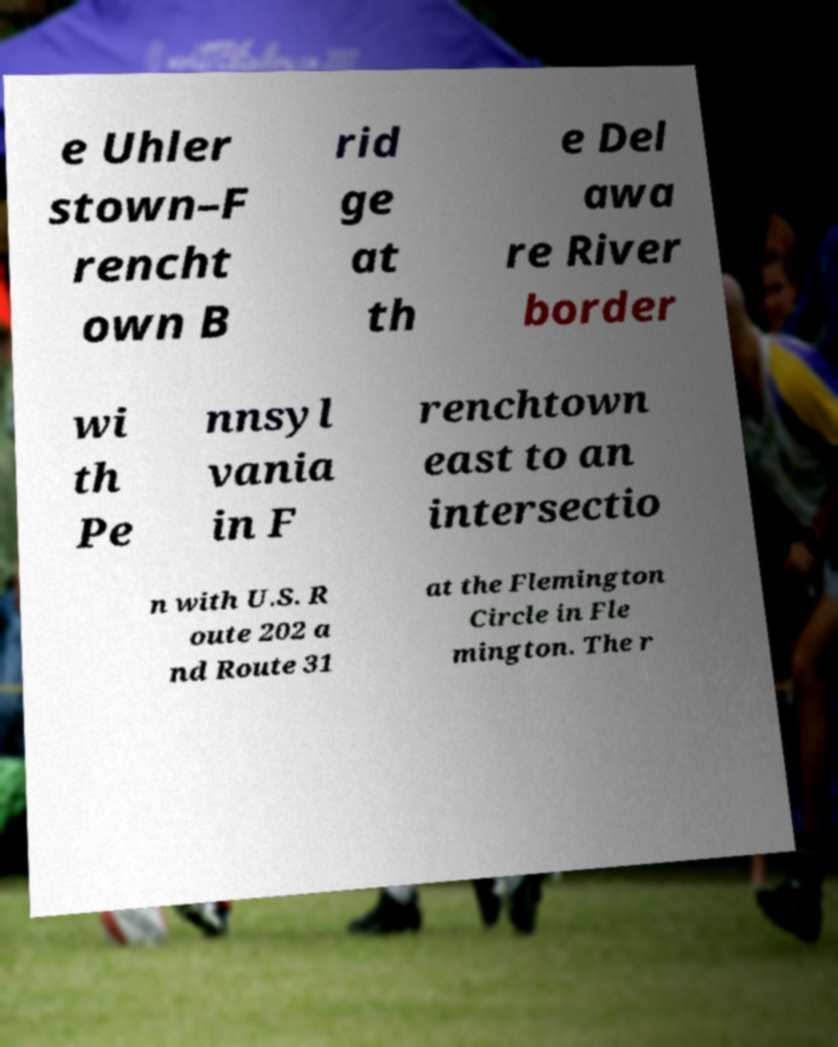Please identify and transcribe the text found in this image. e Uhler stown–F rencht own B rid ge at th e Del awa re River border wi th Pe nnsyl vania in F renchtown east to an intersectio n with U.S. R oute 202 a nd Route 31 at the Flemington Circle in Fle mington. The r 